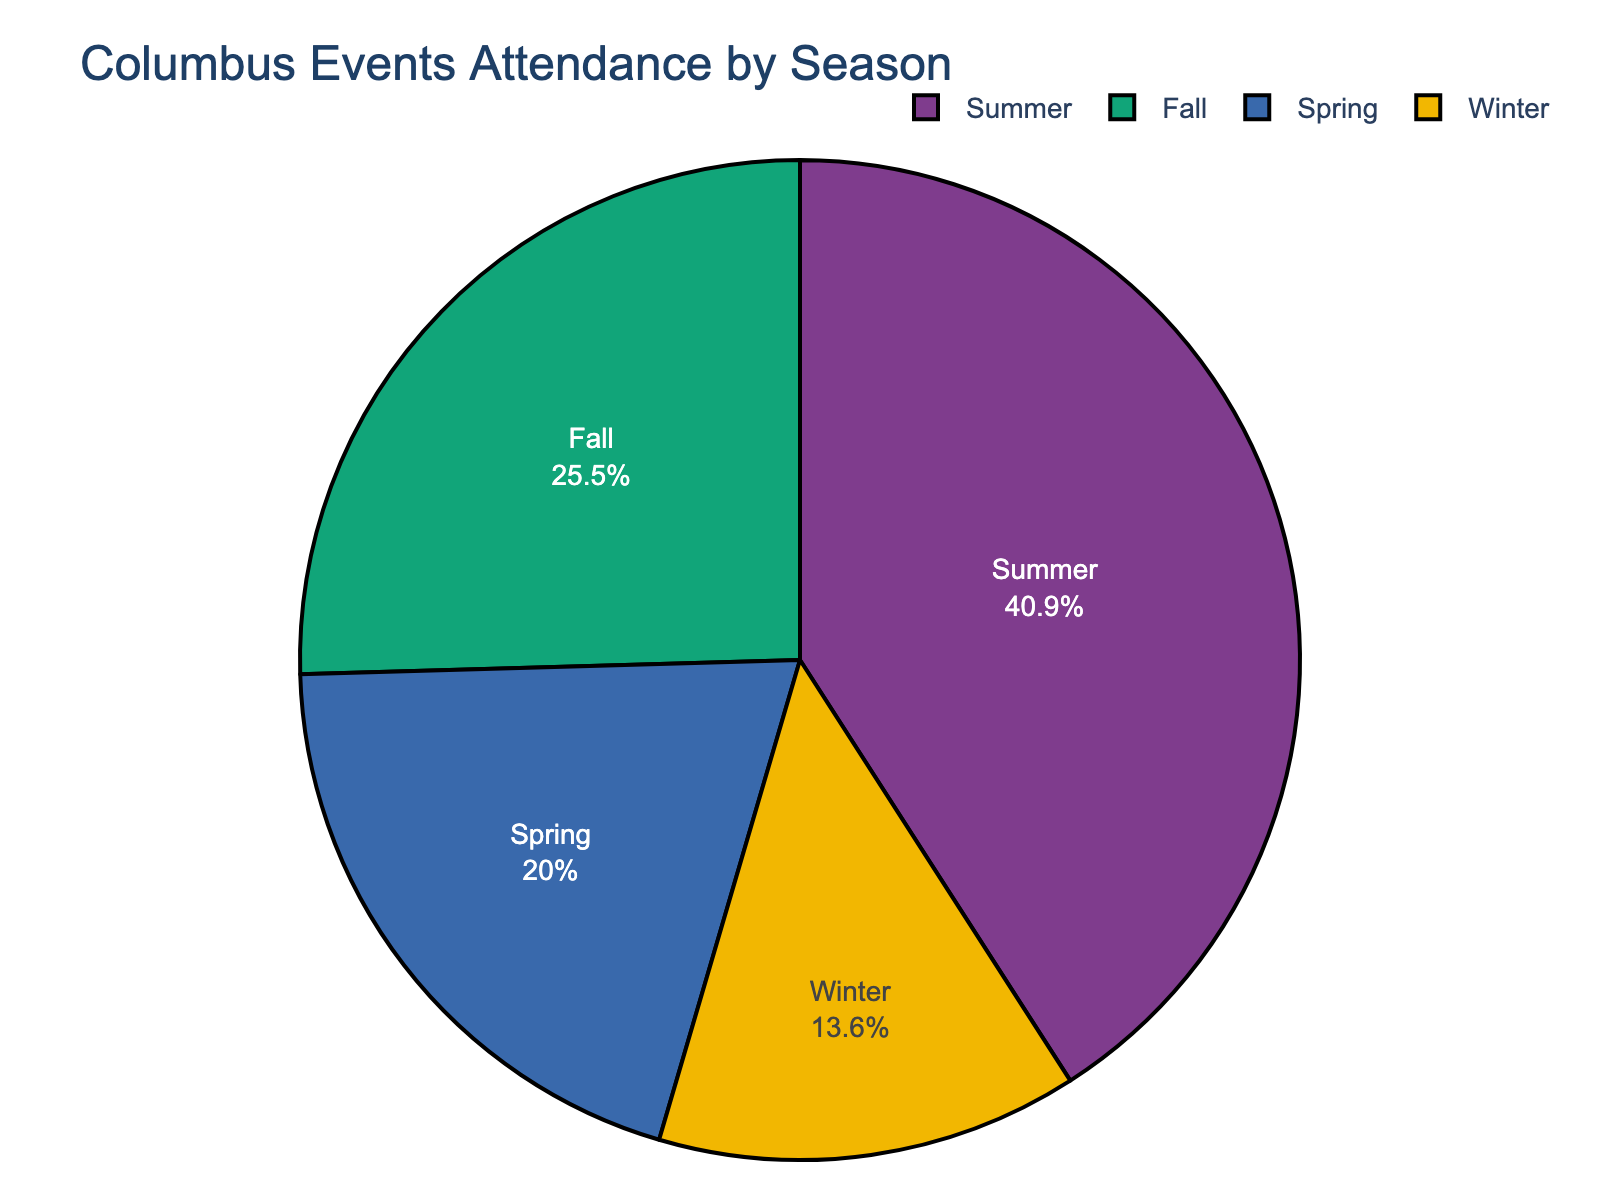Which season has the highest attendance for events in Columbus? The pie chart displays the highest attendance slice with the label "Summer," meaning Summer has the highest attendance for events in Columbus.
Answer: Summer What percentage of the total attendance occurs during Winter? The pie chart shows the percentage labels for each season. The slice labeled "Winter" displays "14.29%", representing Winter's attendance percentage.
Answer: 14.29% How much greater is the attendance in the Summer compared to the Winter? Summer has 450,000 attendees, and Winter has 150,000. The difference is calculated as 450,000 - 150,000.
Answer: 300,000 What is the total attendance for Fall and Spring combined? Fall has 280,000 attendees, and Spring has 220,000. The sum is 280,000 + 220,000.
Answer: 500,000 Which season has the smallest attendance? The smallest slice in the pie chart is labeled "Winter," indicating that Winter has the smallest attendance.
Answer: Winter How do the attendances in Fall and Winter compare visually from largest to smallest? By comparing the pie slices, Fall's slice is larger than Winter's slice, indicating that Fall has higher attendance than Winter.
Answer: Fall, Winter What percentage of the total attendance occurs in Fall and Winter combined? Fall's percentage is 26.67%, and Winter's percentage is 14.29%. Adding these gives 26.67% + 14.29%.
Answer: 40.96% Is the Spring attendance more or less than half of the Summer attendance? Summer has 450,000 attendees, half of this is 225,000. Spring has 220,000 attendees, which is less than half of Summer's attendance.
Answer: Less If the total annual attendance is 1,100,000, what is the average attendance per season? Total annual attendance is 1,100,000. Dividing by 4 (the number of seasons), the average per season is 1,100,000 / 4.
Answer: 275,000 Among Spring, Fall, and Winter, which season has the highest attendance? By comparing the slices for Spring, Fall, and Winter, Fall's slice is the largest, indicating that Fall has the highest attendance among the three.
Answer: Fall 